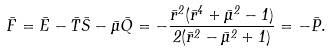Convert formula to latex. <formula><loc_0><loc_0><loc_500><loc_500>\bar { F } = \bar { E } - \bar { T } \bar { S } - \bar { \mu } \bar { Q } = - \frac { \bar { r } ^ { 2 } ( \bar { r } ^ { 4 } + \bar { \mu } ^ { 2 } - 1 ) } { 2 ( \bar { r } ^ { 2 } - \bar { \mu } ^ { 2 } + 1 ) } = - \bar { P } .</formula> 